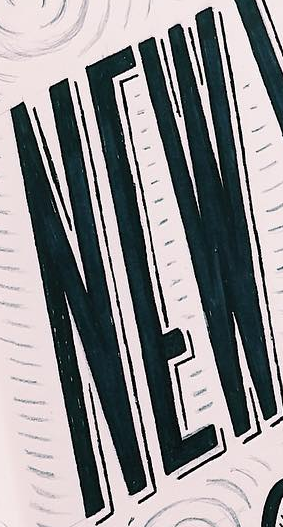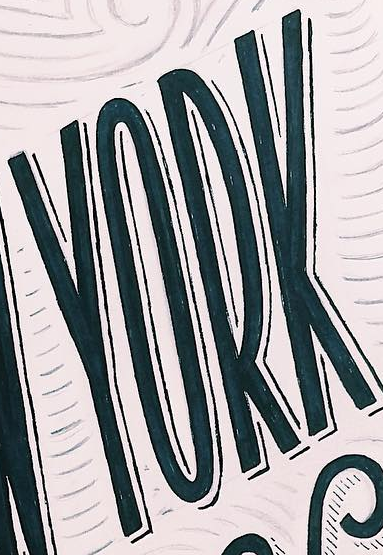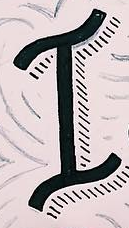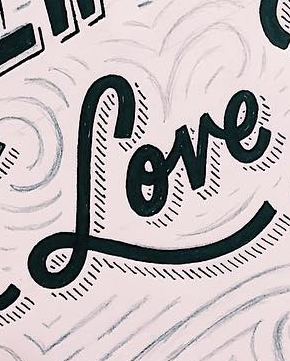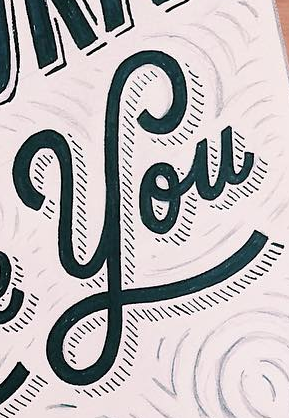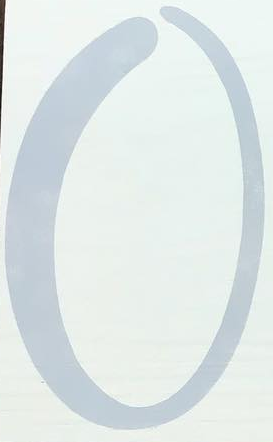Transcribe the words shown in these images in order, separated by a semicolon. NEW; YORK; I; Love; You; O 